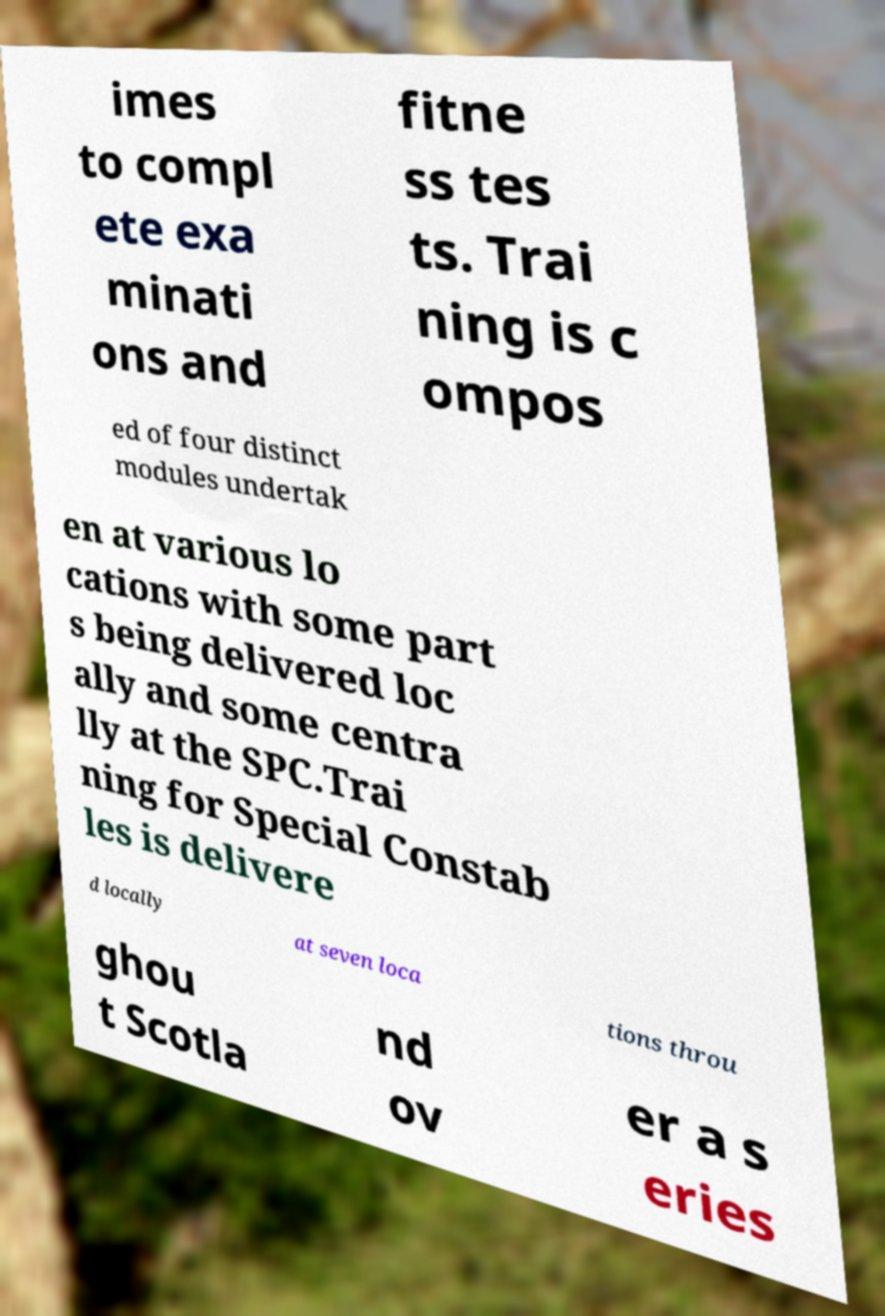Could you assist in decoding the text presented in this image and type it out clearly? imes to compl ete exa minati ons and fitne ss tes ts. Trai ning is c ompos ed of four distinct modules undertak en at various lo cations with some part s being delivered loc ally and some centra lly at the SPC.Trai ning for Special Constab les is delivere d locally at seven loca tions throu ghou t Scotla nd ov er a s eries 